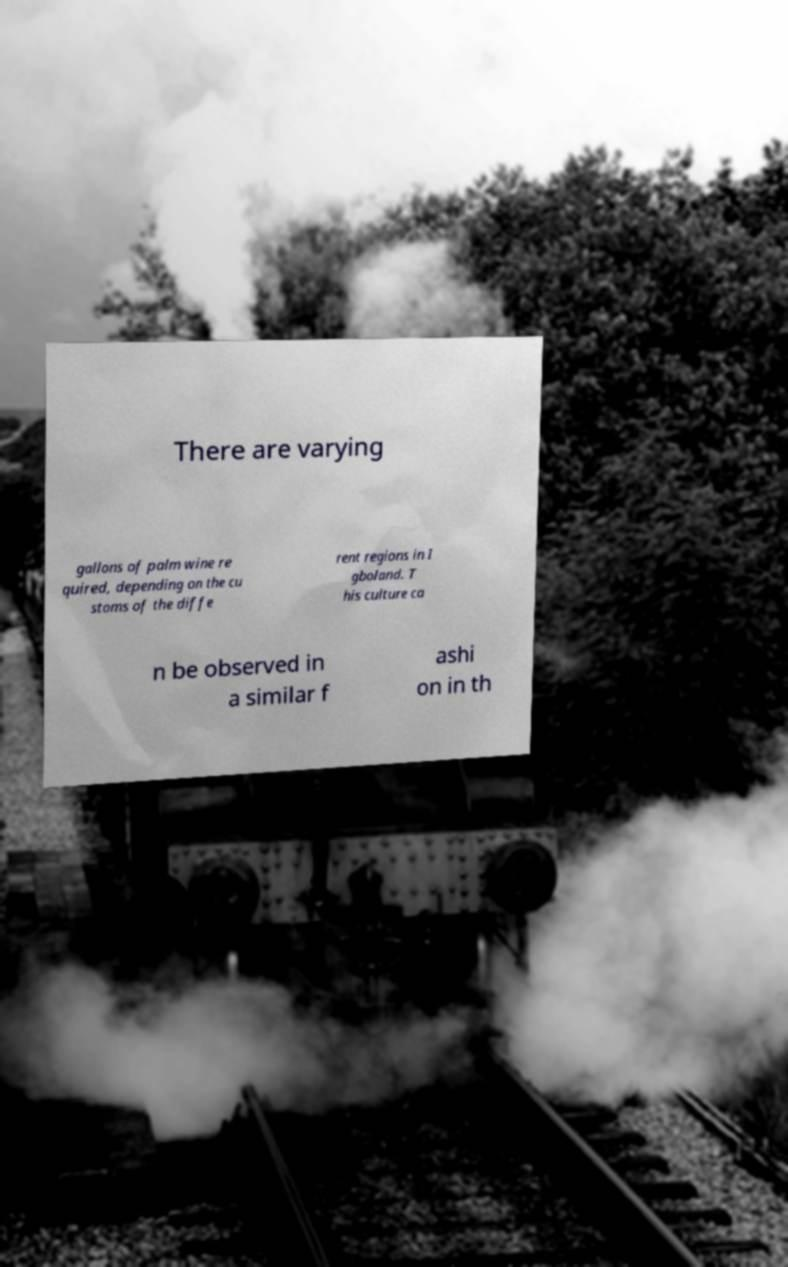Could you extract and type out the text from this image? There are varying gallons of palm wine re quired, depending on the cu stoms of the diffe rent regions in I gboland. T his culture ca n be observed in a similar f ashi on in th 